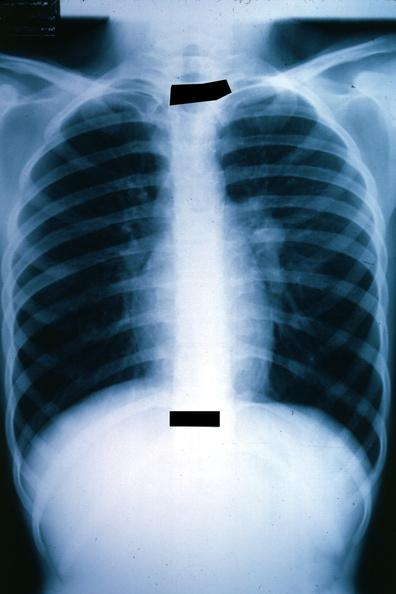what is present?
Answer the question using a single word or phrase. Metastatic malignant ependymoma 